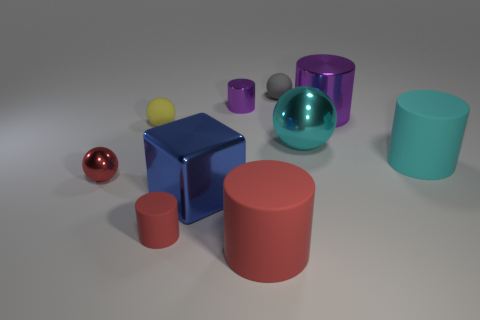There is a big thing that is both in front of the cyan matte object and right of the metallic cube; what is its shape? cylinder 